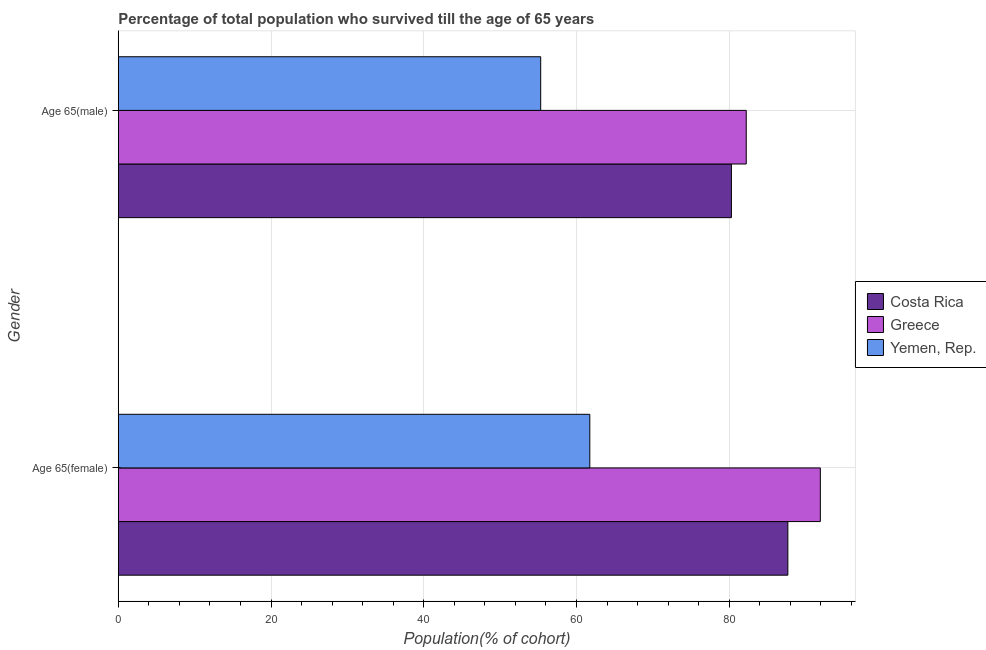Are the number of bars per tick equal to the number of legend labels?
Keep it short and to the point. Yes. Are the number of bars on each tick of the Y-axis equal?
Provide a short and direct response. Yes. What is the label of the 1st group of bars from the top?
Offer a very short reply. Age 65(male). What is the percentage of male population who survived till age of 65 in Yemen, Rep.?
Offer a very short reply. 55.31. Across all countries, what is the maximum percentage of male population who survived till age of 65?
Ensure brevity in your answer.  82.23. Across all countries, what is the minimum percentage of male population who survived till age of 65?
Offer a terse response. 55.31. In which country was the percentage of female population who survived till age of 65 minimum?
Your answer should be compact. Yemen, Rep. What is the total percentage of male population who survived till age of 65 in the graph?
Provide a short and direct response. 217.83. What is the difference between the percentage of female population who survived till age of 65 in Costa Rica and that in Yemen, Rep.?
Ensure brevity in your answer.  25.93. What is the difference between the percentage of male population who survived till age of 65 in Yemen, Rep. and the percentage of female population who survived till age of 65 in Costa Rica?
Offer a very short reply. -32.37. What is the average percentage of female population who survived till age of 65 per country?
Offer a very short reply. 80.45. What is the difference between the percentage of female population who survived till age of 65 and percentage of male population who survived till age of 65 in Yemen, Rep.?
Your answer should be compact. 6.43. In how many countries, is the percentage of female population who survived till age of 65 greater than 44 %?
Offer a terse response. 3. What is the ratio of the percentage of female population who survived till age of 65 in Greece to that in Costa Rica?
Make the answer very short. 1.05. In how many countries, is the percentage of female population who survived till age of 65 greater than the average percentage of female population who survived till age of 65 taken over all countries?
Your answer should be compact. 2. What does the 2nd bar from the top in Age 65(male) represents?
Offer a terse response. Greece. What does the 3rd bar from the bottom in Age 65(female) represents?
Offer a very short reply. Yemen, Rep. How many bars are there?
Provide a short and direct response. 6. Are all the bars in the graph horizontal?
Your response must be concise. Yes. How many countries are there in the graph?
Make the answer very short. 3. What is the difference between two consecutive major ticks on the X-axis?
Provide a succinct answer. 20. Are the values on the major ticks of X-axis written in scientific E-notation?
Ensure brevity in your answer.  No. Does the graph contain grids?
Your response must be concise. Yes. How many legend labels are there?
Your response must be concise. 3. How are the legend labels stacked?
Give a very brief answer. Vertical. What is the title of the graph?
Make the answer very short. Percentage of total population who survived till the age of 65 years. Does "Curacao" appear as one of the legend labels in the graph?
Keep it short and to the point. No. What is the label or title of the X-axis?
Your response must be concise. Population(% of cohort). What is the label or title of the Y-axis?
Give a very brief answer. Gender. What is the Population(% of cohort) of Costa Rica in Age 65(female)?
Provide a short and direct response. 87.68. What is the Population(% of cohort) in Greece in Age 65(female)?
Offer a terse response. 91.93. What is the Population(% of cohort) in Yemen, Rep. in Age 65(female)?
Offer a terse response. 61.75. What is the Population(% of cohort) in Costa Rica in Age 65(male)?
Provide a short and direct response. 80.29. What is the Population(% of cohort) in Greece in Age 65(male)?
Provide a short and direct response. 82.23. What is the Population(% of cohort) in Yemen, Rep. in Age 65(male)?
Make the answer very short. 55.31. Across all Gender, what is the maximum Population(% of cohort) of Costa Rica?
Your answer should be compact. 87.68. Across all Gender, what is the maximum Population(% of cohort) in Greece?
Offer a terse response. 91.93. Across all Gender, what is the maximum Population(% of cohort) in Yemen, Rep.?
Your answer should be very brief. 61.75. Across all Gender, what is the minimum Population(% of cohort) in Costa Rica?
Ensure brevity in your answer.  80.29. Across all Gender, what is the minimum Population(% of cohort) in Greece?
Your answer should be compact. 82.23. Across all Gender, what is the minimum Population(% of cohort) in Yemen, Rep.?
Keep it short and to the point. 55.31. What is the total Population(% of cohort) of Costa Rica in the graph?
Offer a terse response. 167.97. What is the total Population(% of cohort) of Greece in the graph?
Offer a very short reply. 174.17. What is the total Population(% of cohort) of Yemen, Rep. in the graph?
Offer a very short reply. 117.06. What is the difference between the Population(% of cohort) in Costa Rica in Age 65(female) and that in Age 65(male)?
Offer a terse response. 7.39. What is the difference between the Population(% of cohort) in Greece in Age 65(female) and that in Age 65(male)?
Provide a succinct answer. 9.7. What is the difference between the Population(% of cohort) in Yemen, Rep. in Age 65(female) and that in Age 65(male)?
Offer a terse response. 6.43. What is the difference between the Population(% of cohort) in Costa Rica in Age 65(female) and the Population(% of cohort) in Greece in Age 65(male)?
Offer a terse response. 5.45. What is the difference between the Population(% of cohort) of Costa Rica in Age 65(female) and the Population(% of cohort) of Yemen, Rep. in Age 65(male)?
Provide a succinct answer. 32.37. What is the difference between the Population(% of cohort) of Greece in Age 65(female) and the Population(% of cohort) of Yemen, Rep. in Age 65(male)?
Make the answer very short. 36.62. What is the average Population(% of cohort) in Costa Rica per Gender?
Offer a very short reply. 83.98. What is the average Population(% of cohort) in Greece per Gender?
Offer a very short reply. 87.08. What is the average Population(% of cohort) of Yemen, Rep. per Gender?
Ensure brevity in your answer.  58.53. What is the difference between the Population(% of cohort) in Costa Rica and Population(% of cohort) in Greece in Age 65(female)?
Your answer should be very brief. -4.25. What is the difference between the Population(% of cohort) of Costa Rica and Population(% of cohort) of Yemen, Rep. in Age 65(female)?
Your response must be concise. 25.93. What is the difference between the Population(% of cohort) of Greece and Population(% of cohort) of Yemen, Rep. in Age 65(female)?
Your response must be concise. 30.19. What is the difference between the Population(% of cohort) of Costa Rica and Population(% of cohort) of Greece in Age 65(male)?
Make the answer very short. -1.94. What is the difference between the Population(% of cohort) in Costa Rica and Population(% of cohort) in Yemen, Rep. in Age 65(male)?
Your answer should be compact. 24.98. What is the difference between the Population(% of cohort) of Greece and Population(% of cohort) of Yemen, Rep. in Age 65(male)?
Offer a very short reply. 26.92. What is the ratio of the Population(% of cohort) in Costa Rica in Age 65(female) to that in Age 65(male)?
Make the answer very short. 1.09. What is the ratio of the Population(% of cohort) of Greece in Age 65(female) to that in Age 65(male)?
Keep it short and to the point. 1.12. What is the ratio of the Population(% of cohort) of Yemen, Rep. in Age 65(female) to that in Age 65(male)?
Provide a succinct answer. 1.12. What is the difference between the highest and the second highest Population(% of cohort) in Costa Rica?
Give a very brief answer. 7.39. What is the difference between the highest and the second highest Population(% of cohort) in Greece?
Your response must be concise. 9.7. What is the difference between the highest and the second highest Population(% of cohort) of Yemen, Rep.?
Ensure brevity in your answer.  6.43. What is the difference between the highest and the lowest Population(% of cohort) in Costa Rica?
Provide a short and direct response. 7.39. What is the difference between the highest and the lowest Population(% of cohort) of Greece?
Provide a succinct answer. 9.7. What is the difference between the highest and the lowest Population(% of cohort) of Yemen, Rep.?
Your response must be concise. 6.43. 